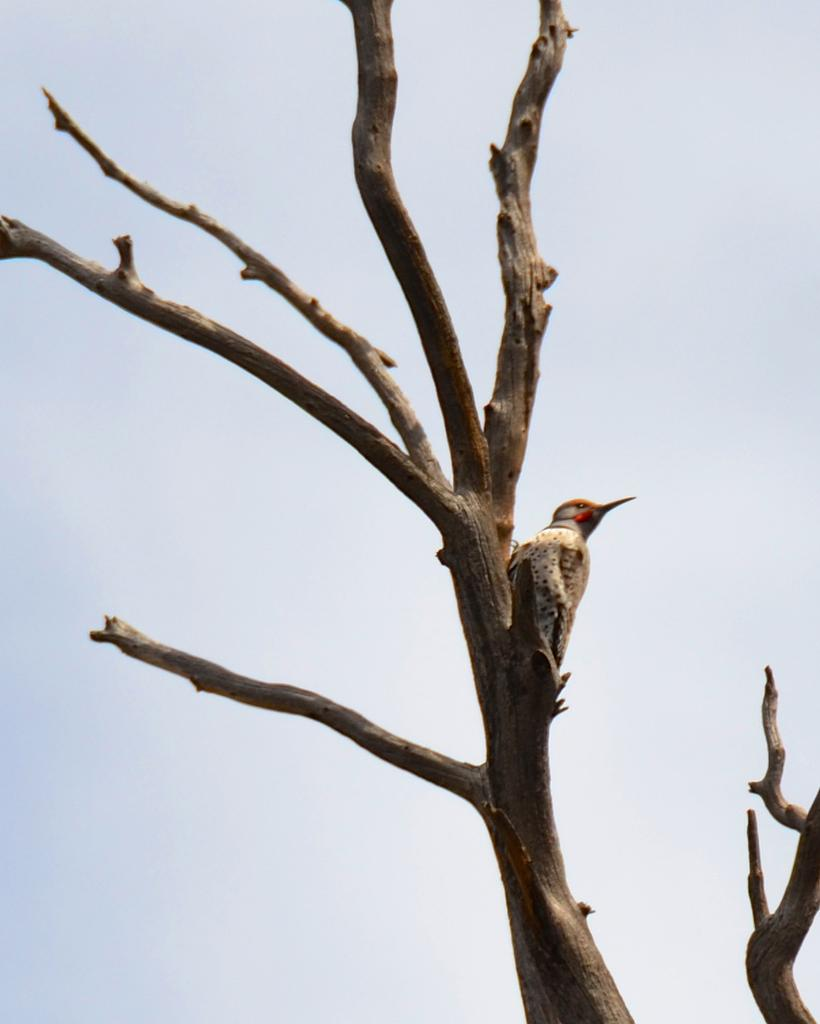What type of bird can be seen in the image? There is a brown color bird in the image. Where is the bird located in the image? The bird is sitting on a dry tree branch. What type of berry is the bird eating in the image? There is no berry present in the image, and the bird is not shown eating anything. 